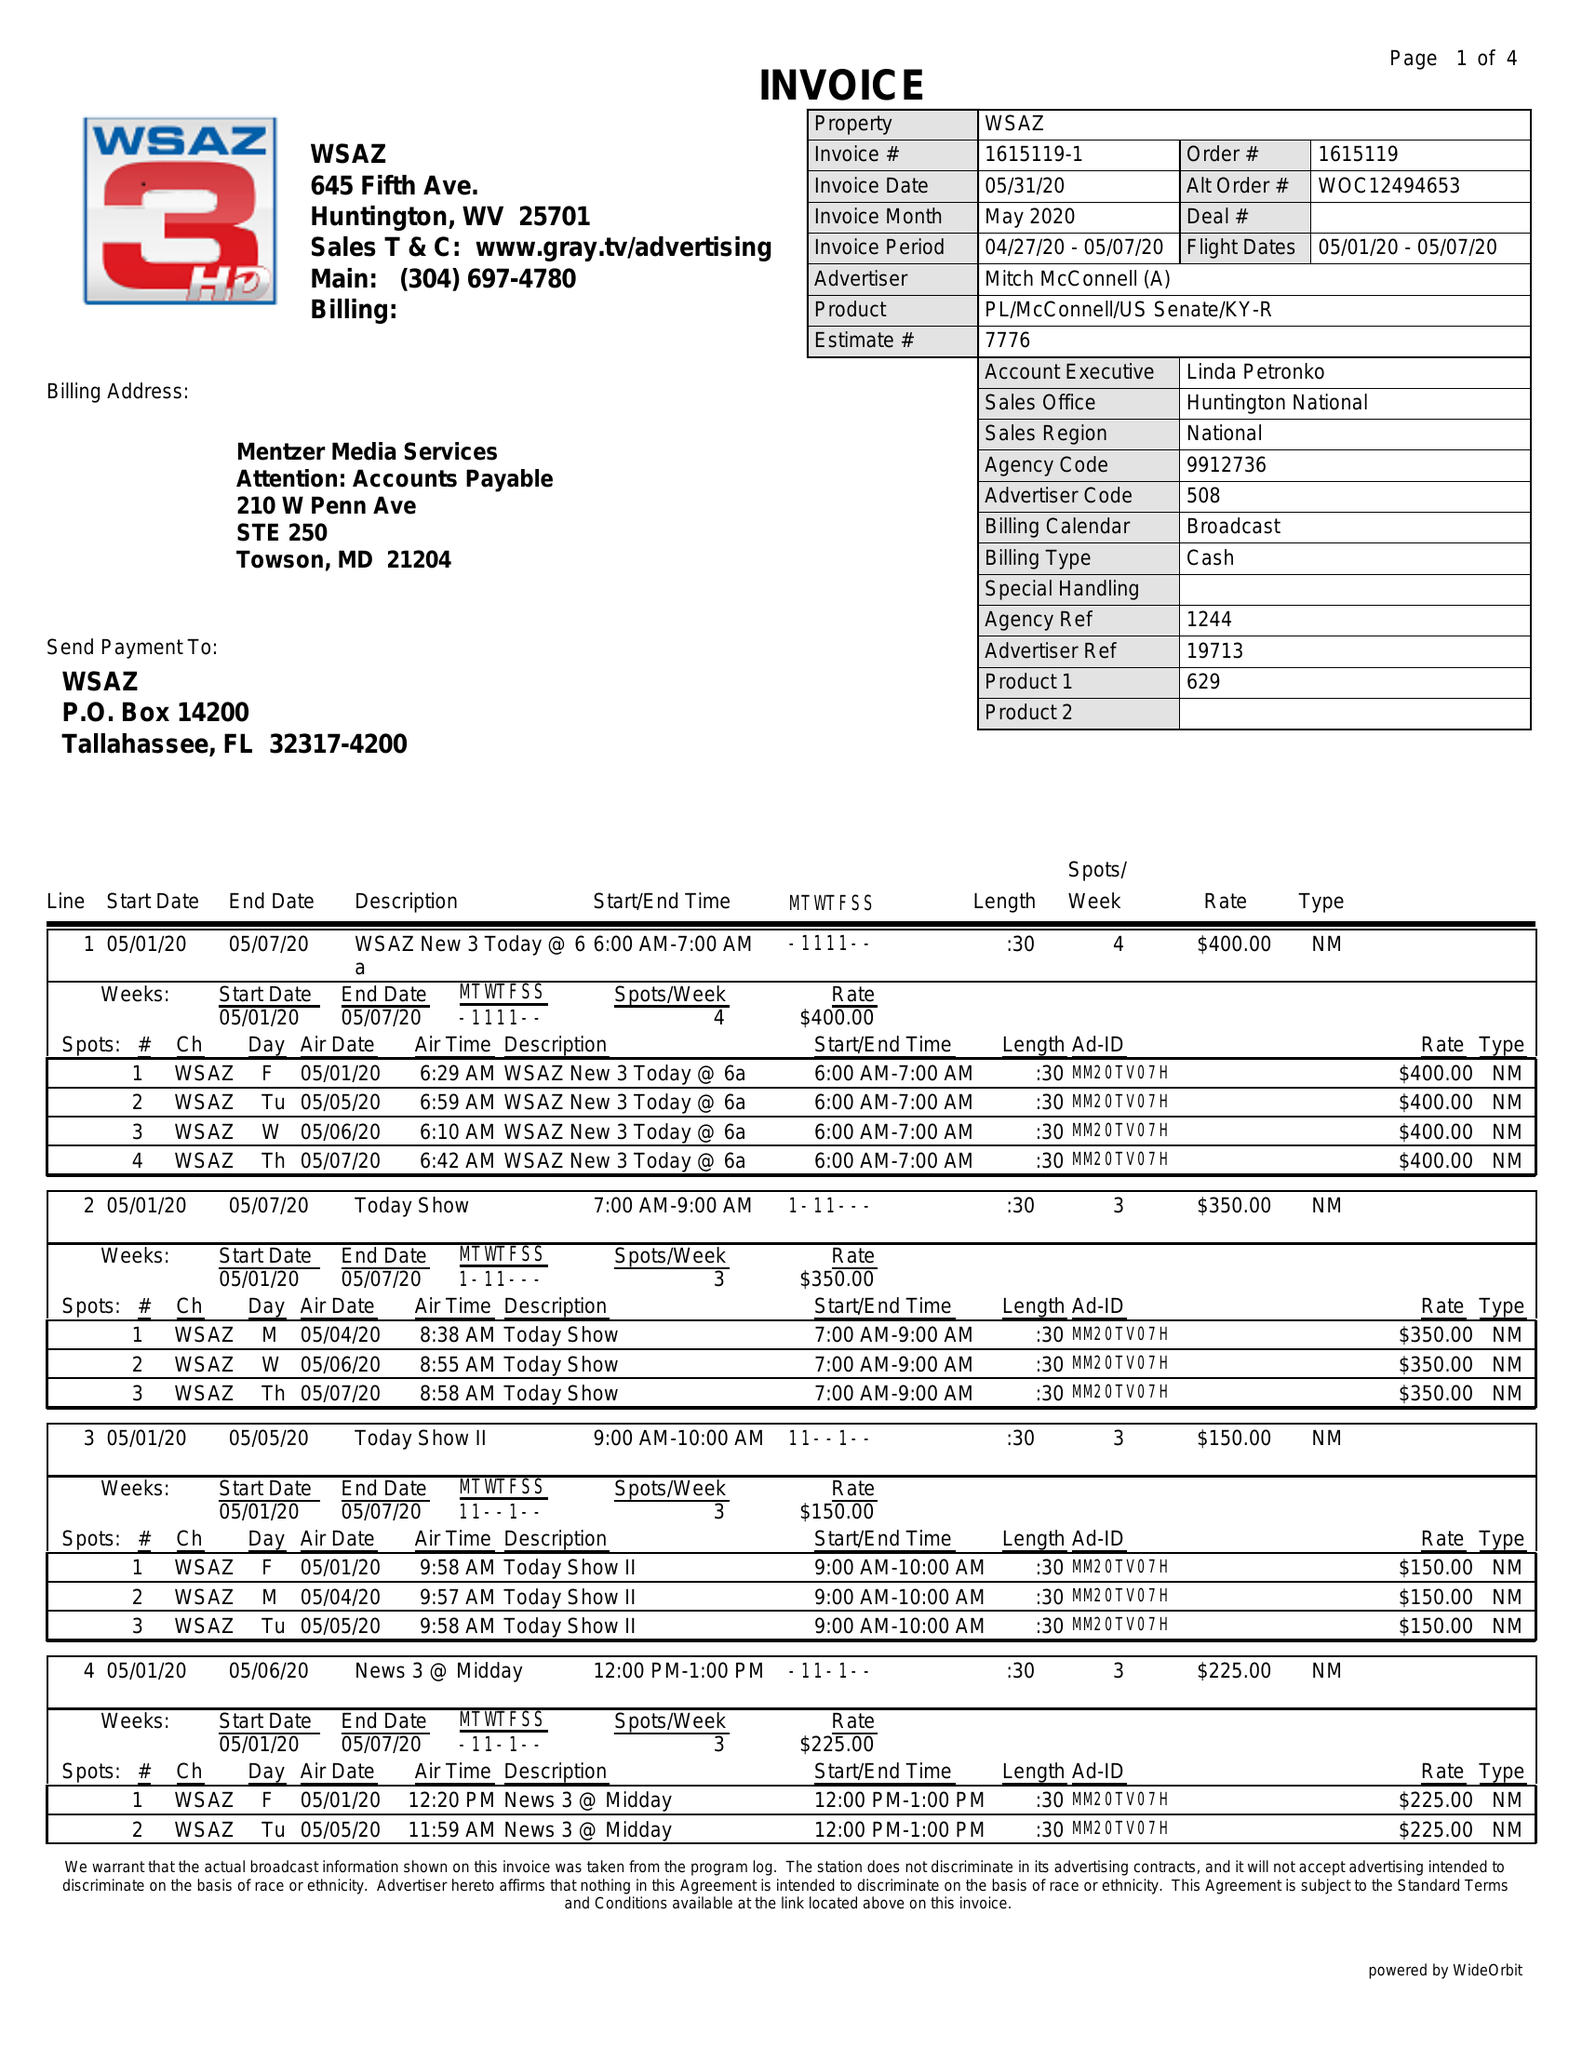What is the value for the contract_num?
Answer the question using a single word or phrase. 1615119 